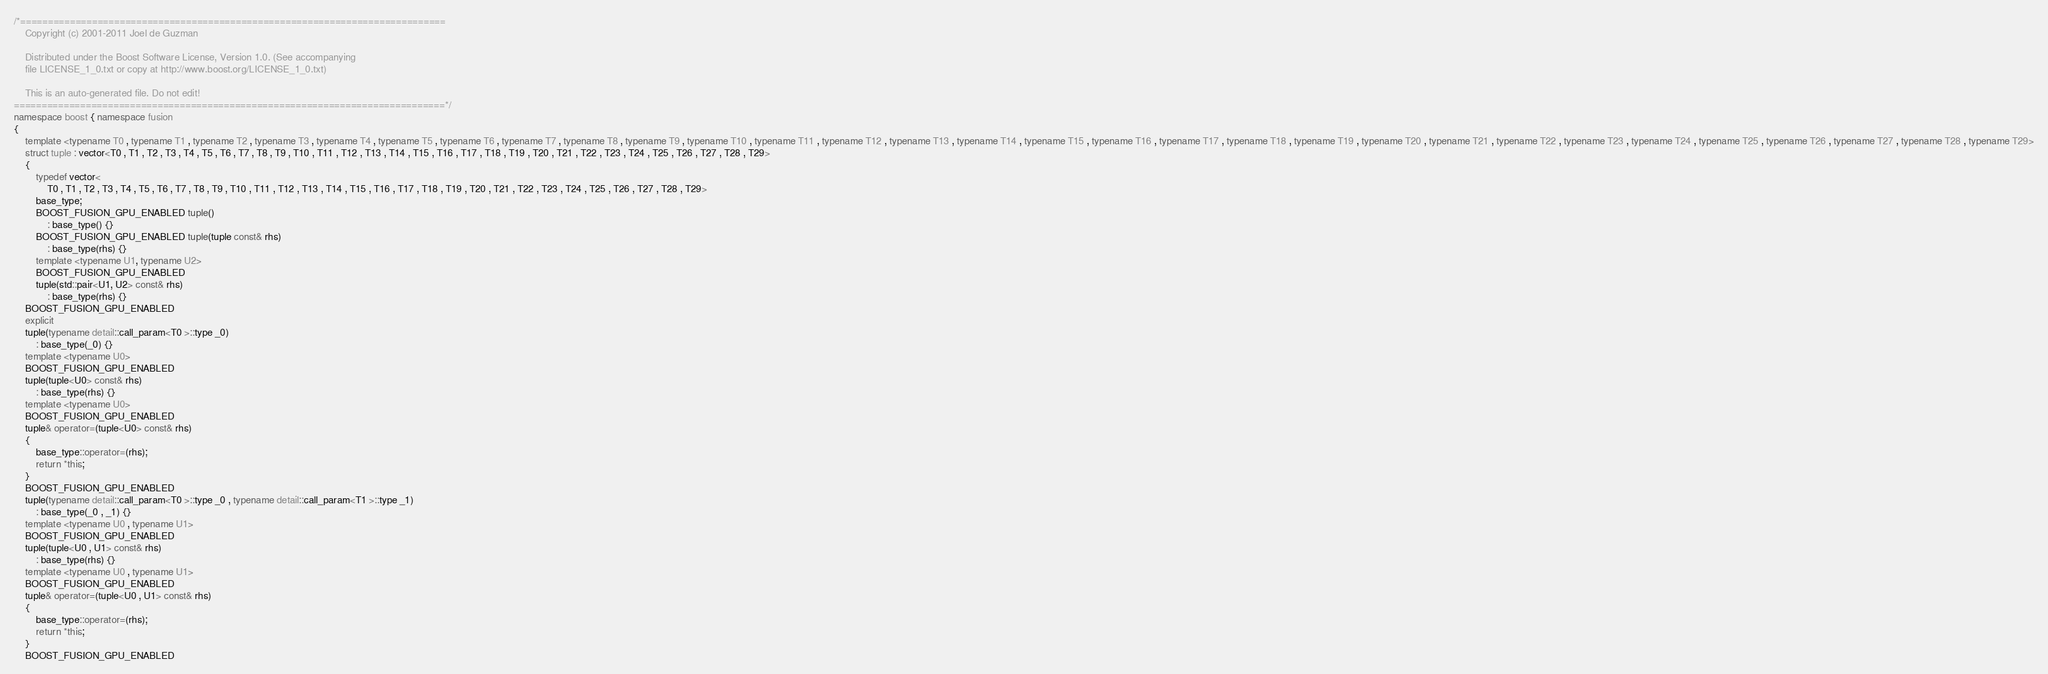Convert code to text. <code><loc_0><loc_0><loc_500><loc_500><_C++_>/*=============================================================================
    Copyright (c) 2001-2011 Joel de Guzman

    Distributed under the Boost Software License, Version 1.0. (See accompanying
    file LICENSE_1_0.txt or copy at http://www.boost.org/LICENSE_1_0.txt)

    This is an auto-generated file. Do not edit!
==============================================================================*/
namespace boost { namespace fusion
{
    template <typename T0 , typename T1 , typename T2 , typename T3 , typename T4 , typename T5 , typename T6 , typename T7 , typename T8 , typename T9 , typename T10 , typename T11 , typename T12 , typename T13 , typename T14 , typename T15 , typename T16 , typename T17 , typename T18 , typename T19 , typename T20 , typename T21 , typename T22 , typename T23 , typename T24 , typename T25 , typename T26 , typename T27 , typename T28 , typename T29>
    struct tuple : vector<T0 , T1 , T2 , T3 , T4 , T5 , T6 , T7 , T8 , T9 , T10 , T11 , T12 , T13 , T14 , T15 , T16 , T17 , T18 , T19 , T20 , T21 , T22 , T23 , T24 , T25 , T26 , T27 , T28 , T29>
    {
        typedef vector<
            T0 , T1 , T2 , T3 , T4 , T5 , T6 , T7 , T8 , T9 , T10 , T11 , T12 , T13 , T14 , T15 , T16 , T17 , T18 , T19 , T20 , T21 , T22 , T23 , T24 , T25 , T26 , T27 , T28 , T29>
        base_type;
        BOOST_FUSION_GPU_ENABLED tuple()
            : base_type() {}
        BOOST_FUSION_GPU_ENABLED tuple(tuple const& rhs)
            : base_type(rhs) {}
        template <typename U1, typename U2>
        BOOST_FUSION_GPU_ENABLED
        tuple(std::pair<U1, U2> const& rhs)
            : base_type(rhs) {}
    BOOST_FUSION_GPU_ENABLED
    explicit
    tuple(typename detail::call_param<T0 >::type _0)
        : base_type(_0) {}
    template <typename U0>
    BOOST_FUSION_GPU_ENABLED
    tuple(tuple<U0> const& rhs)
        : base_type(rhs) {}
    template <typename U0>
    BOOST_FUSION_GPU_ENABLED
    tuple& operator=(tuple<U0> const& rhs)
    {
        base_type::operator=(rhs);
        return *this;
    }
    BOOST_FUSION_GPU_ENABLED
    tuple(typename detail::call_param<T0 >::type _0 , typename detail::call_param<T1 >::type _1)
        : base_type(_0 , _1) {}
    template <typename U0 , typename U1>
    BOOST_FUSION_GPU_ENABLED
    tuple(tuple<U0 , U1> const& rhs)
        : base_type(rhs) {}
    template <typename U0 , typename U1>
    BOOST_FUSION_GPU_ENABLED
    tuple& operator=(tuple<U0 , U1> const& rhs)
    {
        base_type::operator=(rhs);
        return *this;
    }
    BOOST_FUSION_GPU_ENABLED</code> 